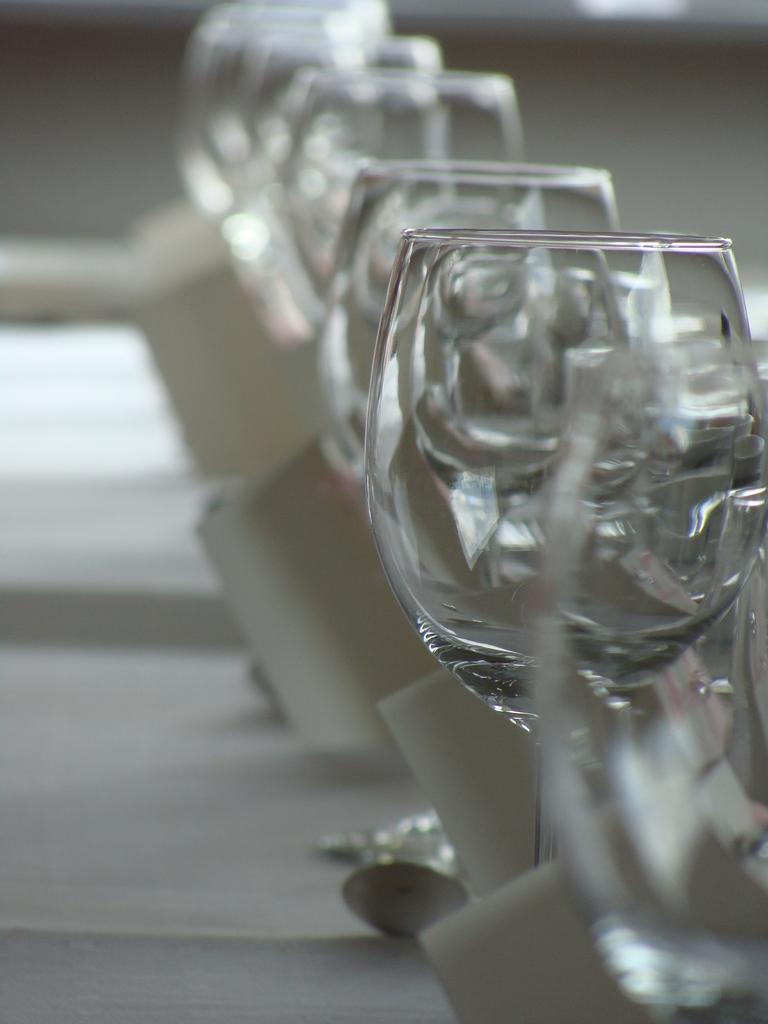What objects are present in the image? There are glasses in the image. What is the color of the surface on which the glasses are placed? The glasses are on a white surface. What type of teaching is being conducted with the glasses in the image? There is no teaching or educational activity depicted in the image; it simply shows glasses on a white surface. 